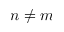Convert formula to latex. <formula><loc_0><loc_0><loc_500><loc_500>n \neq m</formula> 